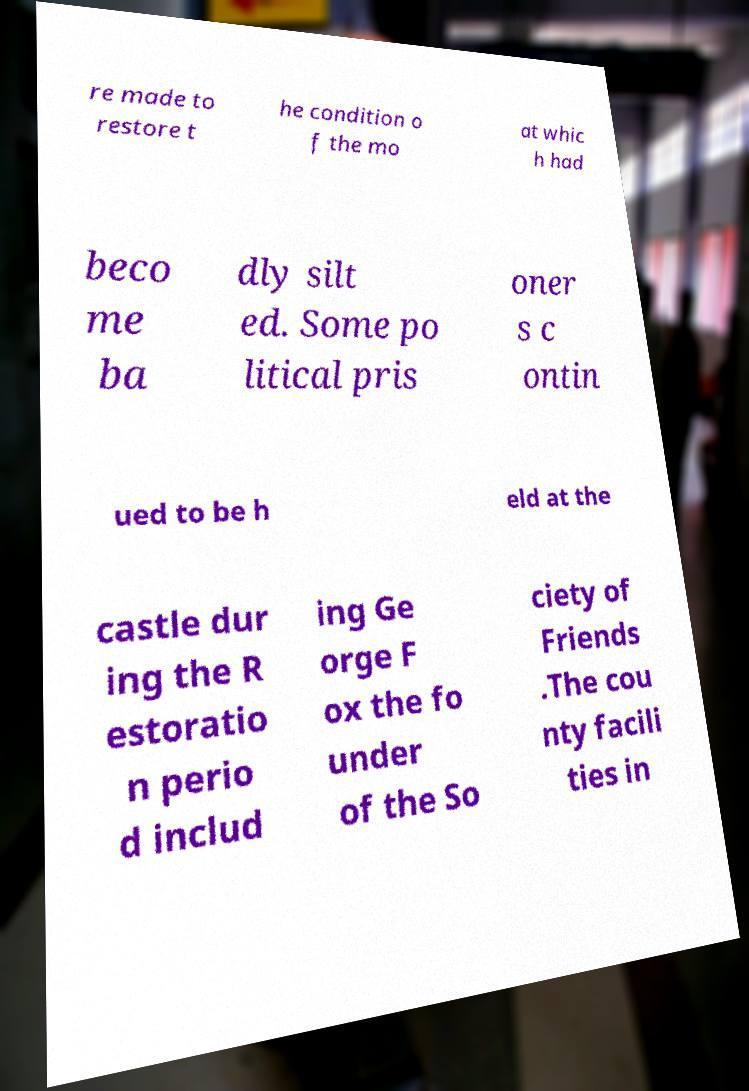Please identify and transcribe the text found in this image. re made to restore t he condition o f the mo at whic h had beco me ba dly silt ed. Some po litical pris oner s c ontin ued to be h eld at the castle dur ing the R estoratio n perio d includ ing Ge orge F ox the fo under of the So ciety of Friends .The cou nty facili ties in 